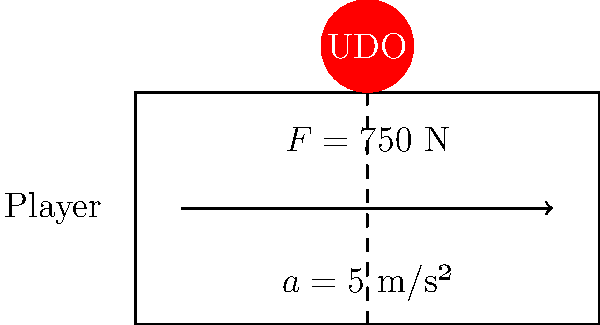During a crucial U.D. Oliveirense match, a player sprints across the field with an acceleration of 5 m/s². If a force of 750 N is applied to the player in the direction of motion, what is the mass of the player? To solve this problem, we'll use Newton's Second Law of Motion, which states that the force acting on an object is equal to its mass times its acceleration. Let's break it down step-by-step:

1. Given information:
   - Force (F) = 750 N
   - Acceleration (a) = 5 m/s²
   - We need to find the mass (m)

2. Newton's Second Law formula:
   $F = ma$

3. Rearrange the formula to solve for mass:
   $m = \frac{F}{a}$

4. Substitute the known values:
   $m = \frac{750 \text{ N}}{5 \text{ m/s²}}$

5. Calculate:
   $m = 150 \text{ kg}$

Therefore, the mass of the player is 150 kg.
Answer: 150 kg 